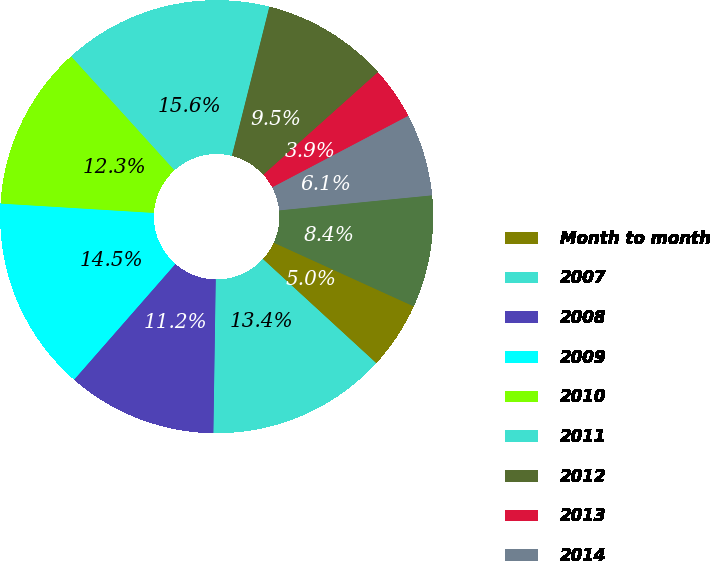<chart> <loc_0><loc_0><loc_500><loc_500><pie_chart><fcel>Month to month<fcel>2007<fcel>2008<fcel>2009<fcel>2010<fcel>2011<fcel>2012<fcel>2013<fcel>2014<fcel>2015<nl><fcel>5.03%<fcel>13.42%<fcel>11.2%<fcel>14.53%<fcel>12.31%<fcel>15.64%<fcel>9.46%<fcel>3.92%<fcel>6.14%<fcel>8.36%<nl></chart> 